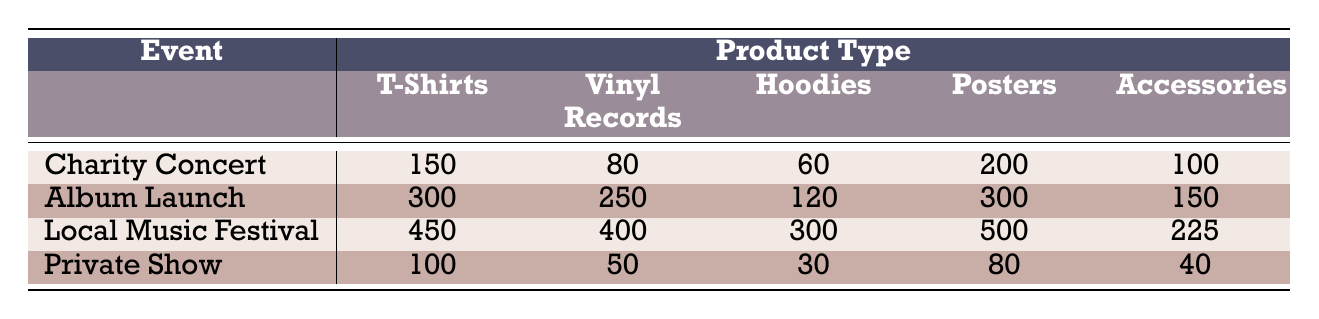What is the total number of T-Shirts sold at the Local Music Festival? The table shows that 450 T-Shirts were sold at the Local Music Festival.
Answer: 450 Which event generated the highest sales of Vinyl Records? By examining the Vinyl Records column, the Album Launch event with 250 sales has higher sales than the others (Charity Concert: 80, Local Music Festival: 400, Private Show: 50).
Answer: Local Music Festival How many more Posters were sold at the Album Launch than at the Private Show? The Album Launch sold 300 Posters and the Private Show sold 80 Posters. The difference is calculated as 300 - 80 = 220.
Answer: 220 What is the average number of Accessories sold across all events? To find the average, sum the Accessories sales: (100 + 150 + 225 + 40) = 515. Divide by 4 events: 515 / 4 = 128.75.
Answer: 128.75 Did the Charity Concert sell more Hoodies than the Private Show? The Charity Concert sold 60 Hoodies while the Private Show sold 30 Hoodies. Therefore, the Charity Concert sold more.
Answer: Yes What is the total merchandise sales for the Local Music Festival? Sum all products sold at the Local Music Festival which includes: 450 (T-Shirts) + 400 (Vinyl Records) + 300 (Hoodies) + 500 (Posters) + 225 (Accessories) = 1875.
Answer: 1875 Which product type has the lowest sales at the Private Show? Referring to the Private Show row: T-Shirts (100), Vinyl Records (50), Hoodies (30), Posters (80), and Accessories (40). The lowest is 30 Hoodies.
Answer: Hoodies If the total sales of T-Shirts in the Album Launch and Local Music Festival are combined, what is the total? The Album Launch sold 300 T-Shirts and the Local Music Festival sold 450. Add them together: 300 + 450 = 750.
Answer: 750 Which event had the most balanced sales across all product types? The Local Music Festival has high sales across all categories, but the Album Launch has the closest sales across its product types: T-Shirts (300), Vinyl Records (250), Hoodies (120), Posters (300), Accessories (150).
Answer: Album Launch What percentage of the total sales at the Charity Concert were from Posters? The total sales at the Charity Concert are 150 (T-Shirts) + 80 (Vinyl Records) + 60 (Hoodies) + 200 (Posters) + 100 (Accessories) = 590. The Posters sold 200. To find the percentage: (200 / 590) * 100 = 33.9%.
Answer: 33.9% 